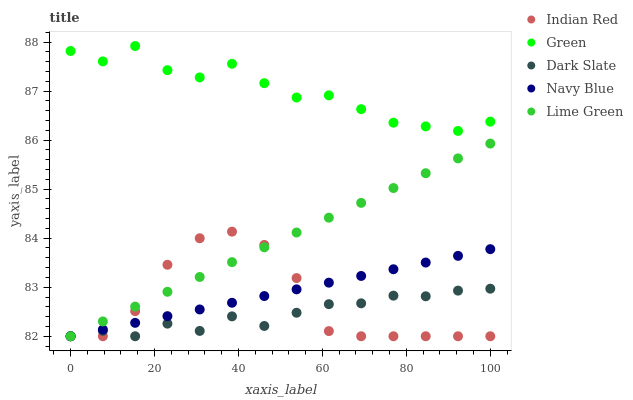Does Dark Slate have the minimum area under the curve?
Answer yes or no. Yes. Does Green have the maximum area under the curve?
Answer yes or no. Yes. Does Green have the minimum area under the curve?
Answer yes or no. No. Does Dark Slate have the maximum area under the curve?
Answer yes or no. No. Is Lime Green the smoothest?
Answer yes or no. Yes. Is Indian Red the roughest?
Answer yes or no. Yes. Is Dark Slate the smoothest?
Answer yes or no. No. Is Dark Slate the roughest?
Answer yes or no. No. Does Lime Green have the lowest value?
Answer yes or no. Yes. Does Green have the lowest value?
Answer yes or no. No. Does Green have the highest value?
Answer yes or no. Yes. Does Dark Slate have the highest value?
Answer yes or no. No. Is Lime Green less than Green?
Answer yes or no. Yes. Is Green greater than Indian Red?
Answer yes or no. Yes. Does Indian Red intersect Dark Slate?
Answer yes or no. Yes. Is Indian Red less than Dark Slate?
Answer yes or no. No. Is Indian Red greater than Dark Slate?
Answer yes or no. No. Does Lime Green intersect Green?
Answer yes or no. No. 